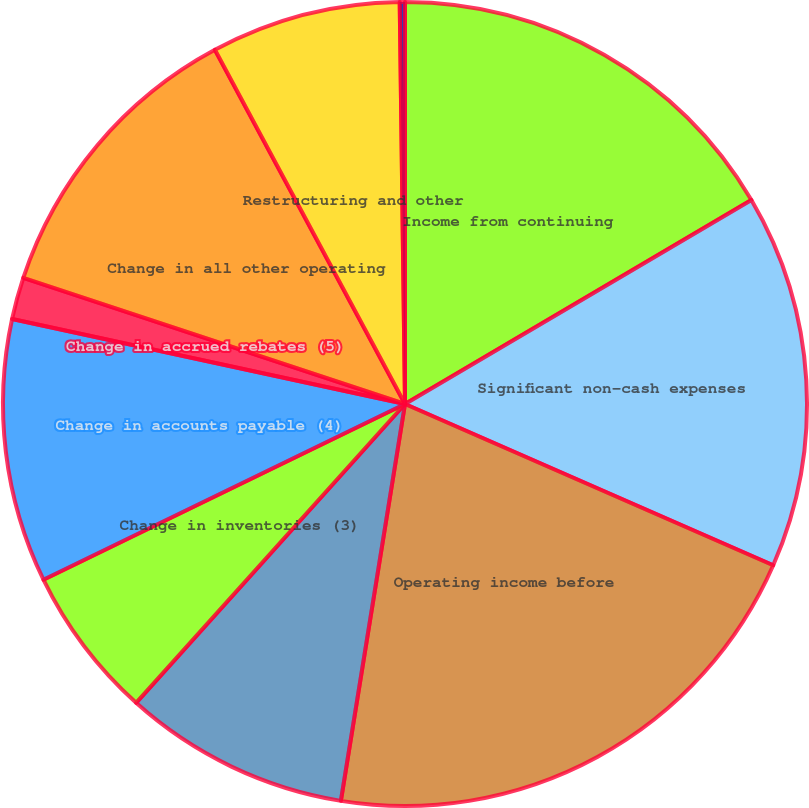Convert chart. <chart><loc_0><loc_0><loc_500><loc_500><pie_chart><fcel>Income from continuing<fcel>Significant non-cash expenses<fcel>Operating income before<fcel>Change in trade receivables<fcel>Change in inventories (3)<fcel>Change in accounts payable (4)<fcel>Change in accrued rebates (5)<fcel>Change in all other operating<fcel>Restructuring and other<fcel>Environmental spending<nl><fcel>16.53%<fcel>15.04%<fcel>20.98%<fcel>9.11%<fcel>6.14%<fcel>10.59%<fcel>1.69%<fcel>12.08%<fcel>7.63%<fcel>0.21%<nl></chart> 